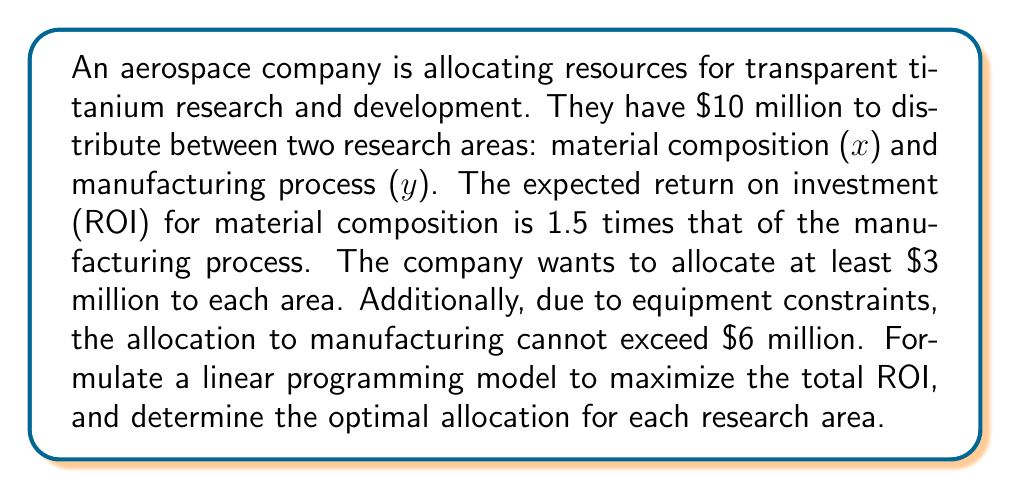Show me your answer to this math problem. Let's approach this step-by-step:

1) Define the variables:
   $x$ = allocation to material composition research (in millions)
   $y$ = allocation to manufacturing process research (in millions)

2) Objective function:
   The ROI for material composition is 1.5 times that of manufacturing. Let's assume the ROI for manufacturing is 1 unit per million dollars. Then, the ROI for material composition is 1.5 units per million dollars.
   
   Maximize: $Z = 1.5x + y$

3) Constraints:
   a) Total budget: $x + y \leq 10$
   b) Minimum allocation for each area: $x \geq 3$ and $y \geq 3$
   c) Maximum allocation for manufacturing: $y \leq 6$
   d) Non-negativity: $x \geq 0$ and $y \geq 0$ (implied by constraint b)

4) The complete linear programming model:

   Maximize: $Z = 1.5x + y$
   Subject to:
   $$\begin{align}
   x + y &\leq 10 \\
   x &\geq 3 \\
   y &\geq 3 \\
   y &\leq 6
   \end{align}$$

5) To solve this, we can use the graphical method:

   [asy]
   import graph;
   size(200);
   xaxis("x", 0, 10, Arrow);
   yaxis("y", 0, 10, Arrow);
   draw((3,0)--(3,7)--(7,3)--(10,0), blue);
   draw((0,3)--(7,3), blue);
   draw((0,6)--(10,6), blue);
   label("Feasible Region", (5,4), green);
   dot((4,6), red);
   label("(4,6)", (4,6), NE);
   [/asy]

6) The feasible region is bounded by the constraints. The optimal solution will be at one of the corner points. We can evaluate the objective function at each corner:

   (3,3): $Z = 1.5(3) + 3 = 7.5$
   (3,6): $Z = 1.5(3) + 6 = 10.5$
   (4,6): $Z = 1.5(4) + 6 = 12$
   (7,3): $Z = 1.5(7) + 3 = 13.5$

7) The maximum value occurs at (7,3), but this violates the total budget constraint. Therefore, the optimal solution is at (4,6).
Answer: The optimal allocation is $4 million to material composition research and $6 million to manufacturing process research, yielding a maximum ROI of 12 units. 